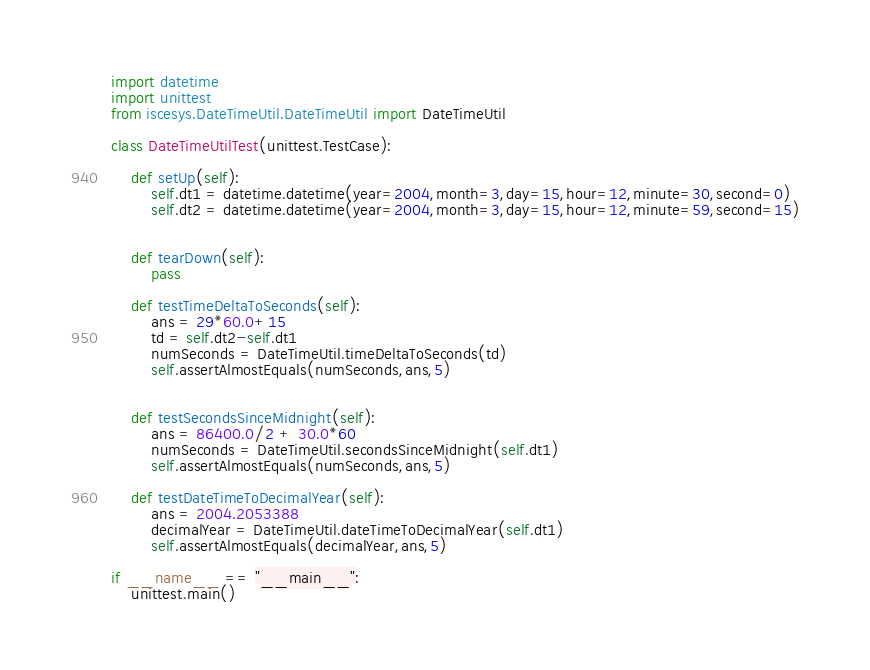<code> <loc_0><loc_0><loc_500><loc_500><_Python_>import datetime
import unittest
from iscesys.DateTimeUtil.DateTimeUtil import DateTimeUtil

class DateTimeUtilTest(unittest.TestCase):

    def setUp(self):
        self.dt1 = datetime.datetime(year=2004,month=3,day=15,hour=12,minute=30,second=0)
        self.dt2 = datetime.datetime(year=2004,month=3,day=15,hour=12,minute=59,second=15)


    def tearDown(self):
        pass

    def testTimeDeltaToSeconds(self):
        ans = 29*60.0+15
        td = self.dt2-self.dt1
        numSeconds = DateTimeUtil.timeDeltaToSeconds(td)
        self.assertAlmostEquals(numSeconds,ans,5)


    def testSecondsSinceMidnight(self):
        ans = 86400.0/2 + 30.0*60
        numSeconds = DateTimeUtil.secondsSinceMidnight(self.dt1)
        self.assertAlmostEquals(numSeconds,ans,5)

    def testDateTimeToDecimalYear(self):
        ans = 2004.2053388
        decimalYear = DateTimeUtil.dateTimeToDecimalYear(self.dt1)
        self.assertAlmostEquals(decimalYear,ans,5)

if __name__ == "__main__":
    unittest.main()
</code> 